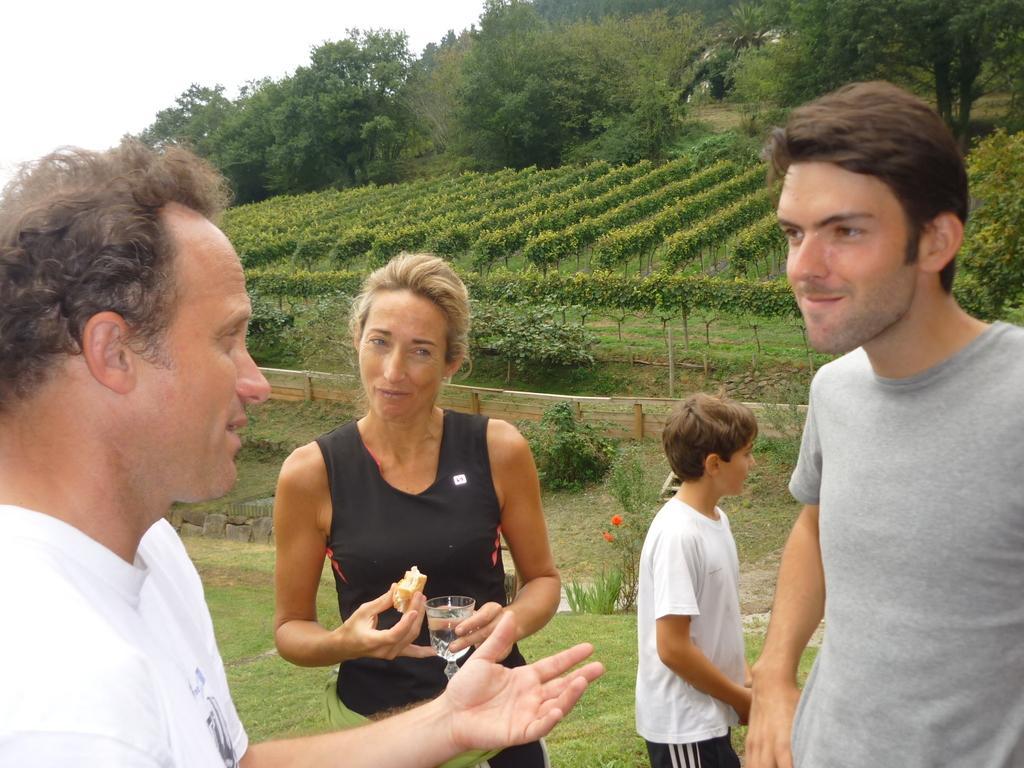Can you describe this image briefly? In this image there is a woman holding a glass and some food. Beside her there is a boy. Right side there is a person standing on the grassland having plants. There is a fence. Behind there are plants. Left side there is a person. Background there are trees. Left top there is sky. 